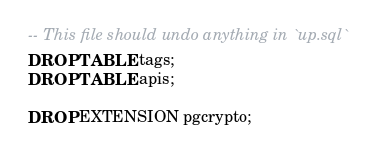<code> <loc_0><loc_0><loc_500><loc_500><_SQL_>-- This file should undo anything in `up.sql`
DROP TABLE tags;
DROP TABLE apis;

DROP EXTENSION pgcrypto;</code> 